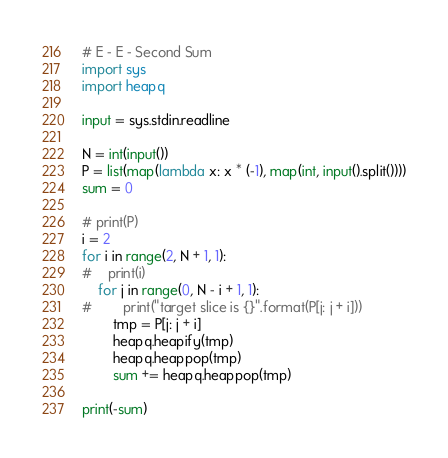Convert code to text. <code><loc_0><loc_0><loc_500><loc_500><_Python_># E - E - Second Sum
import sys
import heapq

input = sys.stdin.readline

N = int(input())
P = list(map(lambda x: x * (-1), map(int, input().split())))
sum = 0

# print(P)
i = 2
for i in range(2, N + 1, 1):
#    print(i)
    for j in range(0, N - i + 1, 1):
#        print("target slice is {}".format(P[j: j + i]))
        tmp = P[j: j + i]
        heapq.heapify(tmp)
        heapq.heappop(tmp)
        sum += heapq.heappop(tmp)

print(-sum)
</code> 